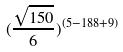Convert formula to latex. <formula><loc_0><loc_0><loc_500><loc_500>( \frac { \sqrt { 1 5 0 } } { 6 } ) ^ { ( 5 - 1 8 8 + 9 ) }</formula> 